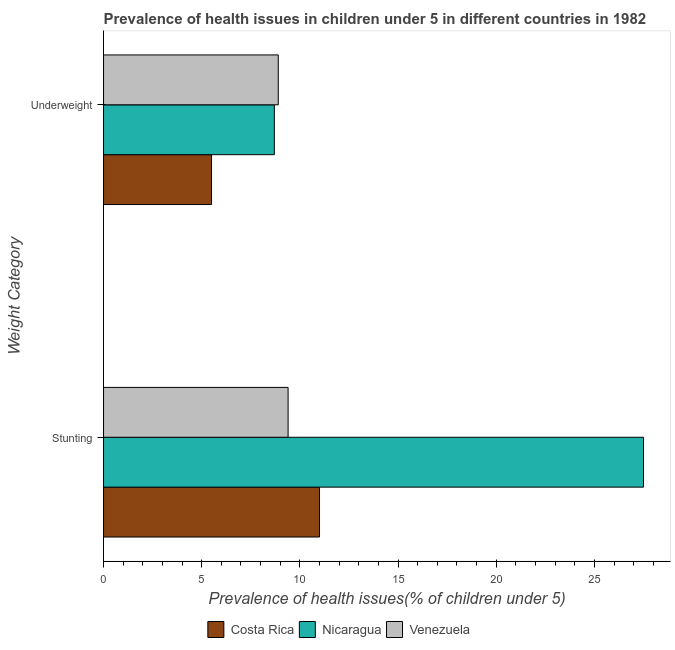Are the number of bars per tick equal to the number of legend labels?
Provide a short and direct response. Yes. How many bars are there on the 1st tick from the bottom?
Give a very brief answer. 3. What is the label of the 2nd group of bars from the top?
Ensure brevity in your answer.  Stunting. What is the percentage of stunted children in Costa Rica?
Your answer should be very brief. 11. Across all countries, what is the minimum percentage of stunted children?
Offer a very short reply. 9.4. In which country was the percentage of underweight children maximum?
Provide a short and direct response. Venezuela. In which country was the percentage of stunted children minimum?
Your answer should be very brief. Venezuela. What is the total percentage of stunted children in the graph?
Ensure brevity in your answer.  47.9. What is the difference between the percentage of underweight children in Nicaragua and that in Venezuela?
Offer a terse response. -0.2. What is the difference between the percentage of underweight children in Nicaragua and the percentage of stunted children in Venezuela?
Give a very brief answer. -0.7. What is the average percentage of stunted children per country?
Keep it short and to the point. 15.97. What is the difference between the percentage of stunted children and percentage of underweight children in Costa Rica?
Your answer should be compact. 5.5. In how many countries, is the percentage of stunted children greater than 21 %?
Keep it short and to the point. 1. What is the ratio of the percentage of stunted children in Costa Rica to that in Venezuela?
Make the answer very short. 1.17. What does the 2nd bar from the top in Underweight represents?
Keep it short and to the point. Nicaragua. What does the 1st bar from the bottom in Underweight represents?
Keep it short and to the point. Costa Rica. How many bars are there?
Give a very brief answer. 6. Does the graph contain grids?
Keep it short and to the point. No. How are the legend labels stacked?
Provide a short and direct response. Horizontal. What is the title of the graph?
Offer a terse response. Prevalence of health issues in children under 5 in different countries in 1982. What is the label or title of the X-axis?
Provide a short and direct response. Prevalence of health issues(% of children under 5). What is the label or title of the Y-axis?
Provide a succinct answer. Weight Category. What is the Prevalence of health issues(% of children under 5) of Venezuela in Stunting?
Offer a terse response. 9.4. What is the Prevalence of health issues(% of children under 5) of Nicaragua in Underweight?
Provide a short and direct response. 8.7. What is the Prevalence of health issues(% of children under 5) in Venezuela in Underweight?
Offer a terse response. 8.9. Across all Weight Category, what is the maximum Prevalence of health issues(% of children under 5) in Nicaragua?
Ensure brevity in your answer.  27.5. Across all Weight Category, what is the maximum Prevalence of health issues(% of children under 5) of Venezuela?
Your answer should be compact. 9.4. Across all Weight Category, what is the minimum Prevalence of health issues(% of children under 5) in Costa Rica?
Offer a terse response. 5.5. Across all Weight Category, what is the minimum Prevalence of health issues(% of children under 5) of Nicaragua?
Offer a terse response. 8.7. Across all Weight Category, what is the minimum Prevalence of health issues(% of children under 5) of Venezuela?
Offer a very short reply. 8.9. What is the total Prevalence of health issues(% of children under 5) in Costa Rica in the graph?
Keep it short and to the point. 16.5. What is the total Prevalence of health issues(% of children under 5) in Nicaragua in the graph?
Offer a very short reply. 36.2. What is the total Prevalence of health issues(% of children under 5) in Venezuela in the graph?
Offer a terse response. 18.3. What is the difference between the Prevalence of health issues(% of children under 5) of Costa Rica in Stunting and that in Underweight?
Offer a very short reply. 5.5. What is the difference between the Prevalence of health issues(% of children under 5) of Nicaragua in Stunting and that in Underweight?
Make the answer very short. 18.8. What is the difference between the Prevalence of health issues(% of children under 5) of Costa Rica in Stunting and the Prevalence of health issues(% of children under 5) of Nicaragua in Underweight?
Your answer should be very brief. 2.3. What is the difference between the Prevalence of health issues(% of children under 5) in Costa Rica in Stunting and the Prevalence of health issues(% of children under 5) in Venezuela in Underweight?
Make the answer very short. 2.1. What is the average Prevalence of health issues(% of children under 5) of Costa Rica per Weight Category?
Offer a very short reply. 8.25. What is the average Prevalence of health issues(% of children under 5) in Venezuela per Weight Category?
Provide a short and direct response. 9.15. What is the difference between the Prevalence of health issues(% of children under 5) in Costa Rica and Prevalence of health issues(% of children under 5) in Nicaragua in Stunting?
Ensure brevity in your answer.  -16.5. What is the difference between the Prevalence of health issues(% of children under 5) of Costa Rica and Prevalence of health issues(% of children under 5) of Venezuela in Stunting?
Give a very brief answer. 1.6. What is the difference between the Prevalence of health issues(% of children under 5) in Nicaragua and Prevalence of health issues(% of children under 5) in Venezuela in Stunting?
Your answer should be compact. 18.1. What is the difference between the Prevalence of health issues(% of children under 5) in Costa Rica and Prevalence of health issues(% of children under 5) in Venezuela in Underweight?
Give a very brief answer. -3.4. What is the ratio of the Prevalence of health issues(% of children under 5) in Nicaragua in Stunting to that in Underweight?
Give a very brief answer. 3.16. What is the ratio of the Prevalence of health issues(% of children under 5) in Venezuela in Stunting to that in Underweight?
Offer a terse response. 1.06. What is the difference between the highest and the second highest Prevalence of health issues(% of children under 5) of Nicaragua?
Your answer should be very brief. 18.8. What is the difference between the highest and the second highest Prevalence of health issues(% of children under 5) in Venezuela?
Provide a succinct answer. 0.5. What is the difference between the highest and the lowest Prevalence of health issues(% of children under 5) of Nicaragua?
Your answer should be compact. 18.8. 